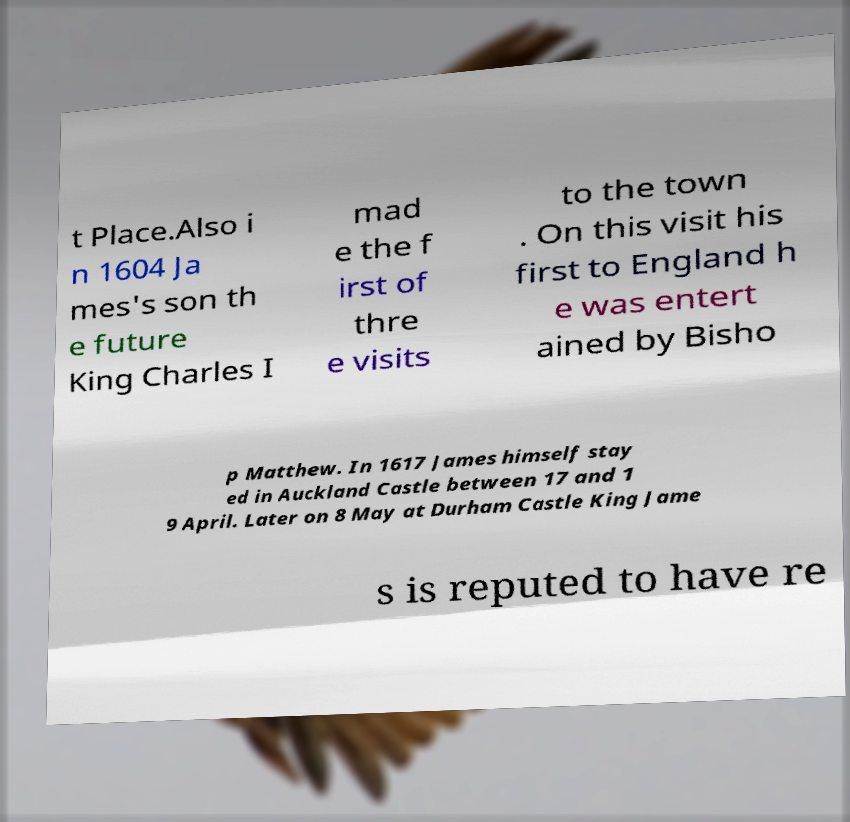Can you read and provide the text displayed in the image?This photo seems to have some interesting text. Can you extract and type it out for me? t Place.Also i n 1604 Ja mes's son th e future King Charles I mad e the f irst of thre e visits to the town . On this visit his first to England h e was entert ained by Bisho p Matthew. In 1617 James himself stay ed in Auckland Castle between 17 and 1 9 April. Later on 8 May at Durham Castle King Jame s is reputed to have re 